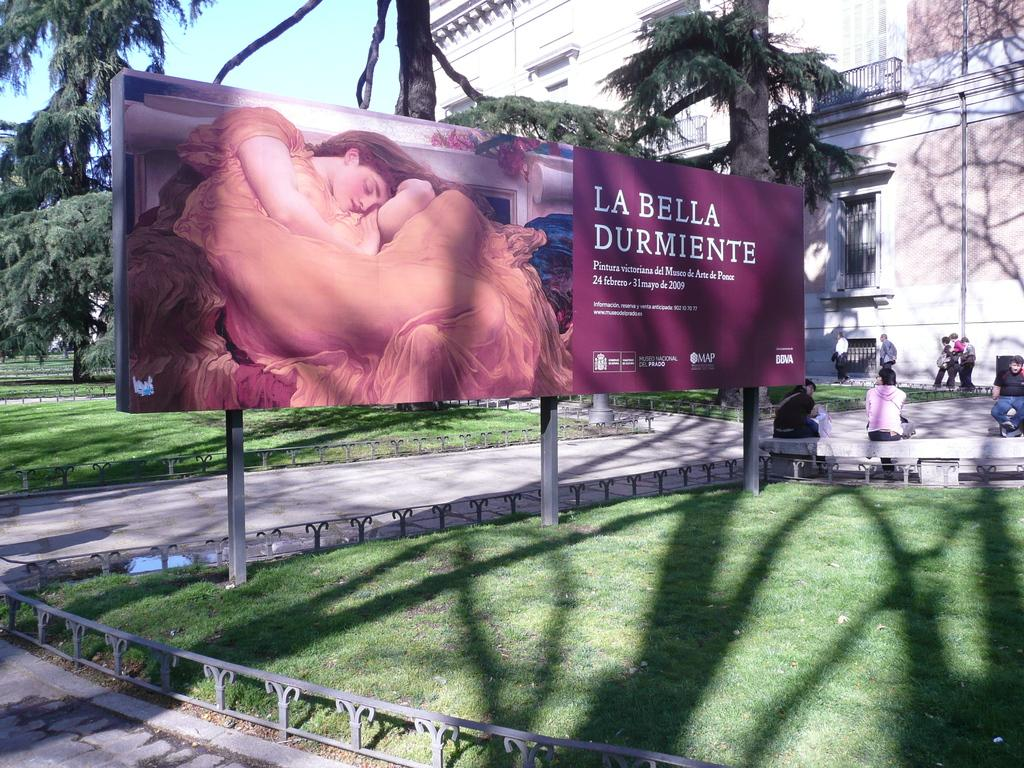Provide a one-sentence caption for the provided image. A large poster advertising La Bella Durmiente in 2009. 